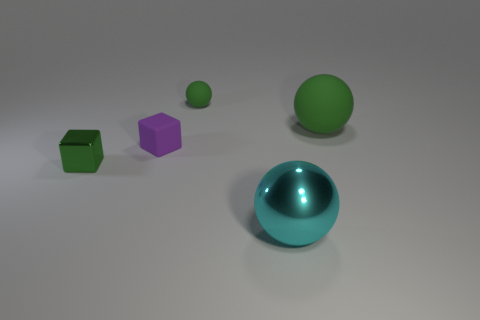Is the large matte object the same color as the small shiny block?
Offer a terse response. Yes. The green object that is to the right of the small purple rubber thing and in front of the small rubber ball is made of what material?
Provide a succinct answer. Rubber. There is a green rubber thing to the left of the shiny object on the right side of the small matte block to the right of the green metallic object; what size is it?
Your answer should be very brief. Small. What is the size of the metallic thing that is left of the large cyan thing?
Offer a terse response. Small. What is the small green thing that is on the right side of the small rubber cube made of?
Your answer should be very brief. Rubber. Does the big green ball have the same material as the tiny thing in front of the tiny purple rubber object?
Your response must be concise. No. Are there the same number of green metallic cubes that are on the right side of the green metal block and matte objects that are right of the small purple matte object?
Your answer should be compact. No. There is a cyan shiny thing; is its size the same as the green sphere that is in front of the tiny matte ball?
Ensure brevity in your answer.  Yes. Is the number of things behind the large shiny sphere greater than the number of large matte balls?
Give a very brief answer. Yes. What number of rubber balls have the same size as the green metal object?
Provide a short and direct response. 1. 